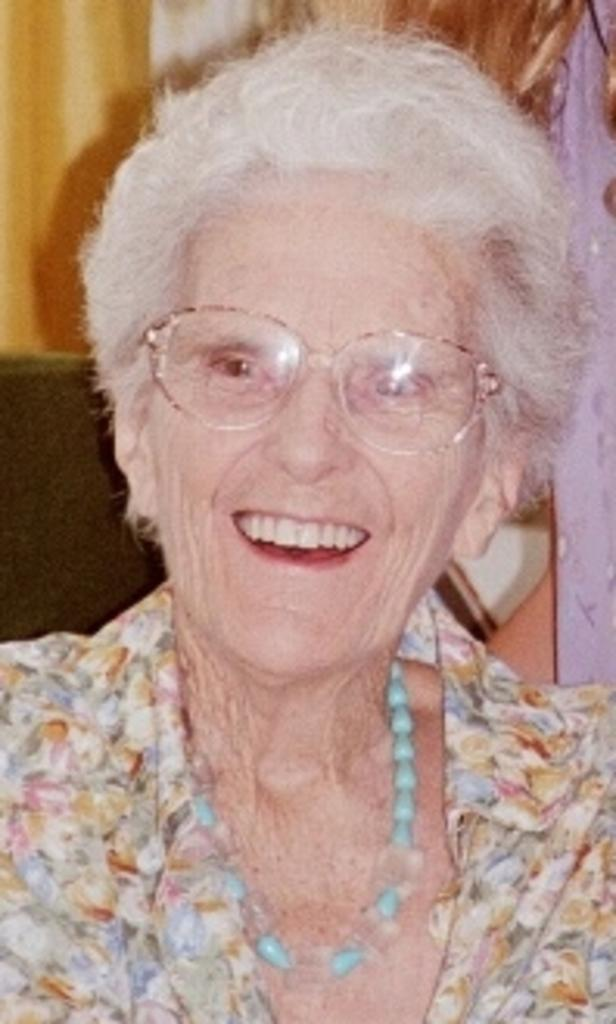Who is present in the image? There is a woman in the image. What is the woman's expression? The woman is smiling. What accessory is the woman wearing? The woman is wearing spectacles. What can be seen in the background of the image? There are objects and a wall in the background of the image. What type of pest can be seen crawling on the woman's spectacles in the image? There is no pest visible on the woman's spectacles in the image. 